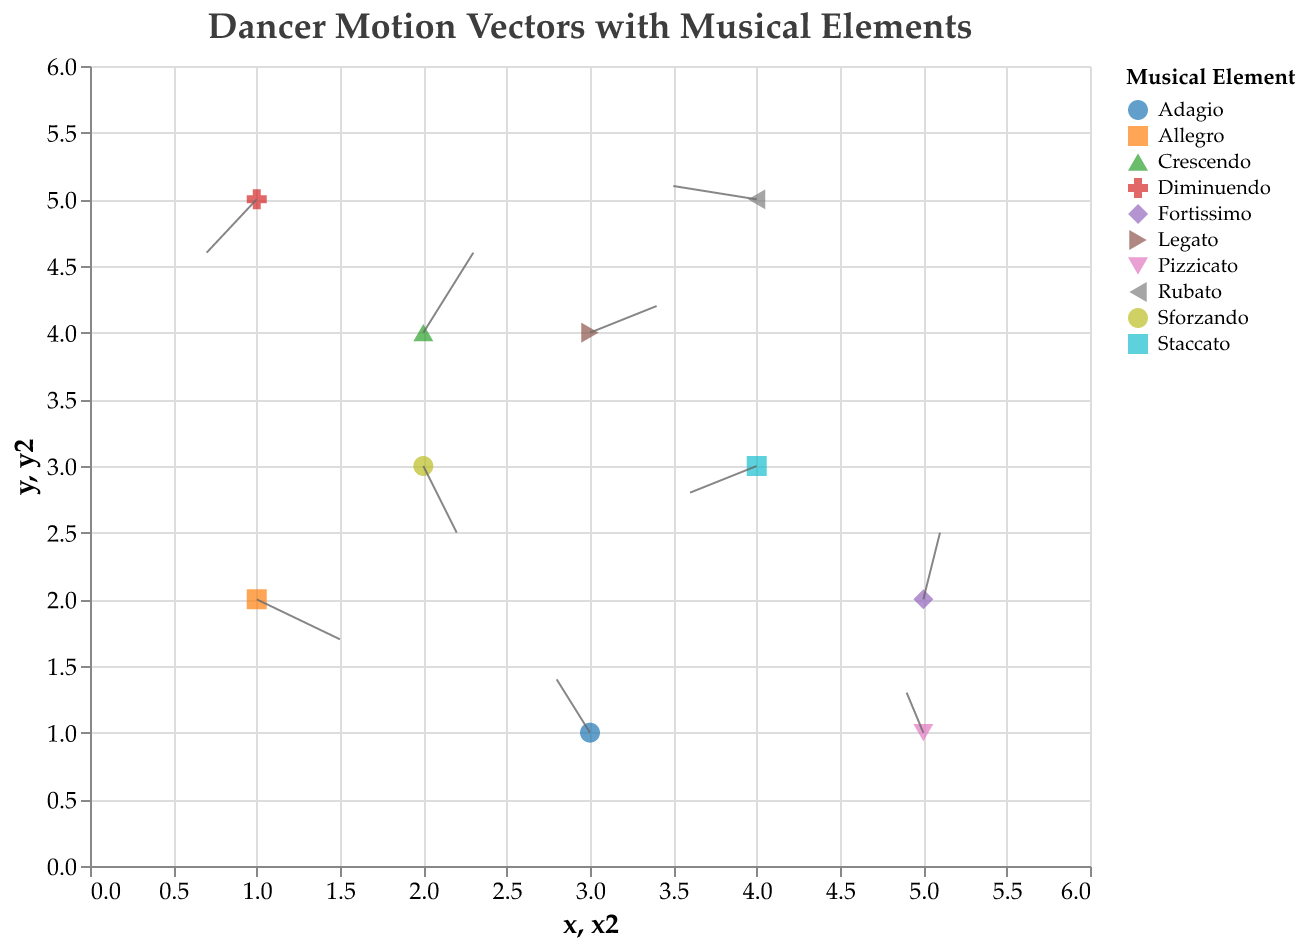What is the title of the figure? The title of the figure is displayed at the top, and it reads "Dancer Motion Vectors with Musical Elements".
Answer: Dancer Motion Vectors with Musical Elements How many points are displayed in the plot? Each point corresponds to a different musical element, and there is a total of 10 rows in the data, indicating 10 points are displayed on the plot.
Answer: 10 Which musical element is located at the coordinates (5, 2)? By examining the coordinates given in the data and the plot, it is clear that the musical element at (5, 2) is Fortissimo.
Answer: Fortissimo Which musical element has the largest motion in the x-direction? By comparing the 'u' values of the data points, the largest motion in the x-direction is 0.5, which corresponds to the Allegro musical element.
Answer: Allegro What is the average vertical motion (v) of all the dancers? To find the average vertical motion, sum all the v values (-0.3, 0.4, 0.6, -0.2, 0.5, -0.4, 0.2, 0.3, -0.5, 0.1) and divide by the number of data points, which is 10. (Total = 1.7, Average = 1.7 / 10)
Answer: 0.17 Which musical elements have negative horizontal motion (u)? By examining the 'u' values, the elements with negative horizontal motion are Adagio (-0.2), Staccato (-0.4), Diminuendo (-0.3), Pizzicato (-0.1), and Rubato (-0.5).
Answer: Adagio, Staccato, Diminuendo, Pizzicato, Rubato Compare the motions of dancers influenced by Crescendo and Rubato. Which one has greater overall magnitude of motion? The motion magnitude is calculated using the formula sqrt(u^2 + v^2). For Crescendo: sqrt(0.3^2 + 0.6^2) = sqrt(0.09 + 0.36) = sqrt(0.45) ≈ 0.67. For Rubato: sqrt(-0.5^2 + 0.1^2) = sqrt(0.25 + 0.01) = sqrt(0.26) ≈ 0.51. Therefore, Crescendo has a greater overall magnitude of motion.
Answer: Crescendo What direction are the dancers influenced by Sforzando moving towards? The direction can be inferred from the movement vector (u, v). For Sforzando, the vector (0.2, -0.5) indicates a movement to the right and downward.
Answer: Right and downward How many musical elements lead to positive vertical motion (v)? By examining the v values, the elements with positive vertical motion are Adagio (0.4), Crescendo (0.6), Fortissimo (0.5), Legato (0.2), and Pizzicato (0.3). In total, there are 5 elements with a positive vertical motion.
Answer: 5 